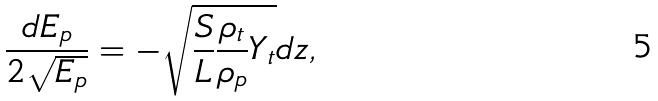<formula> <loc_0><loc_0><loc_500><loc_500>\frac { d E _ { p } } { 2 \sqrt { E _ { p } } } = - \sqrt { \frac { S } { L } \frac { \rho _ { t } } { \rho _ { p } } Y _ { t } } d z ,</formula> 